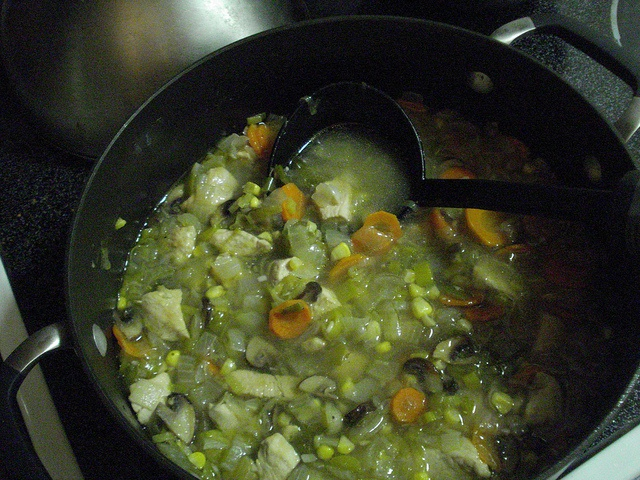Describe the objects in this image and their specific colors. I can see oven in black, olive, gray, and darkgreen tones, spoon in black, navy, gray, and darkgreen tones, broccoli in black, darkgreen, and gray tones, broccoli in black, olive, and gray tones, and carrot in black and olive tones in this image. 